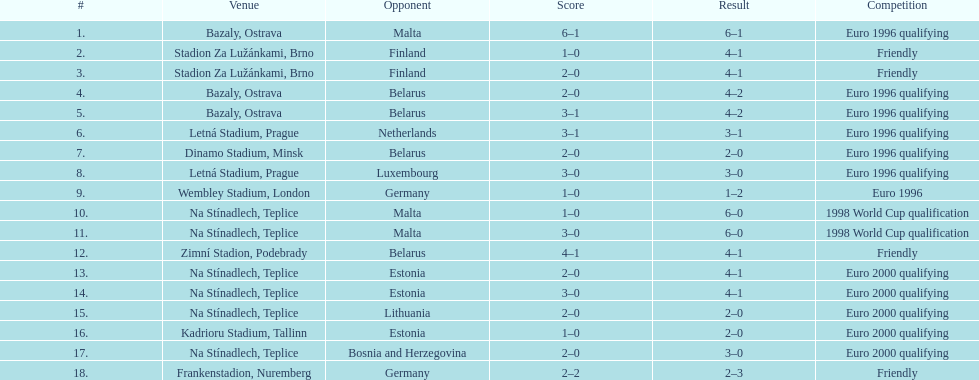How many euro 2000 qualifying competitions are listed? 4. 